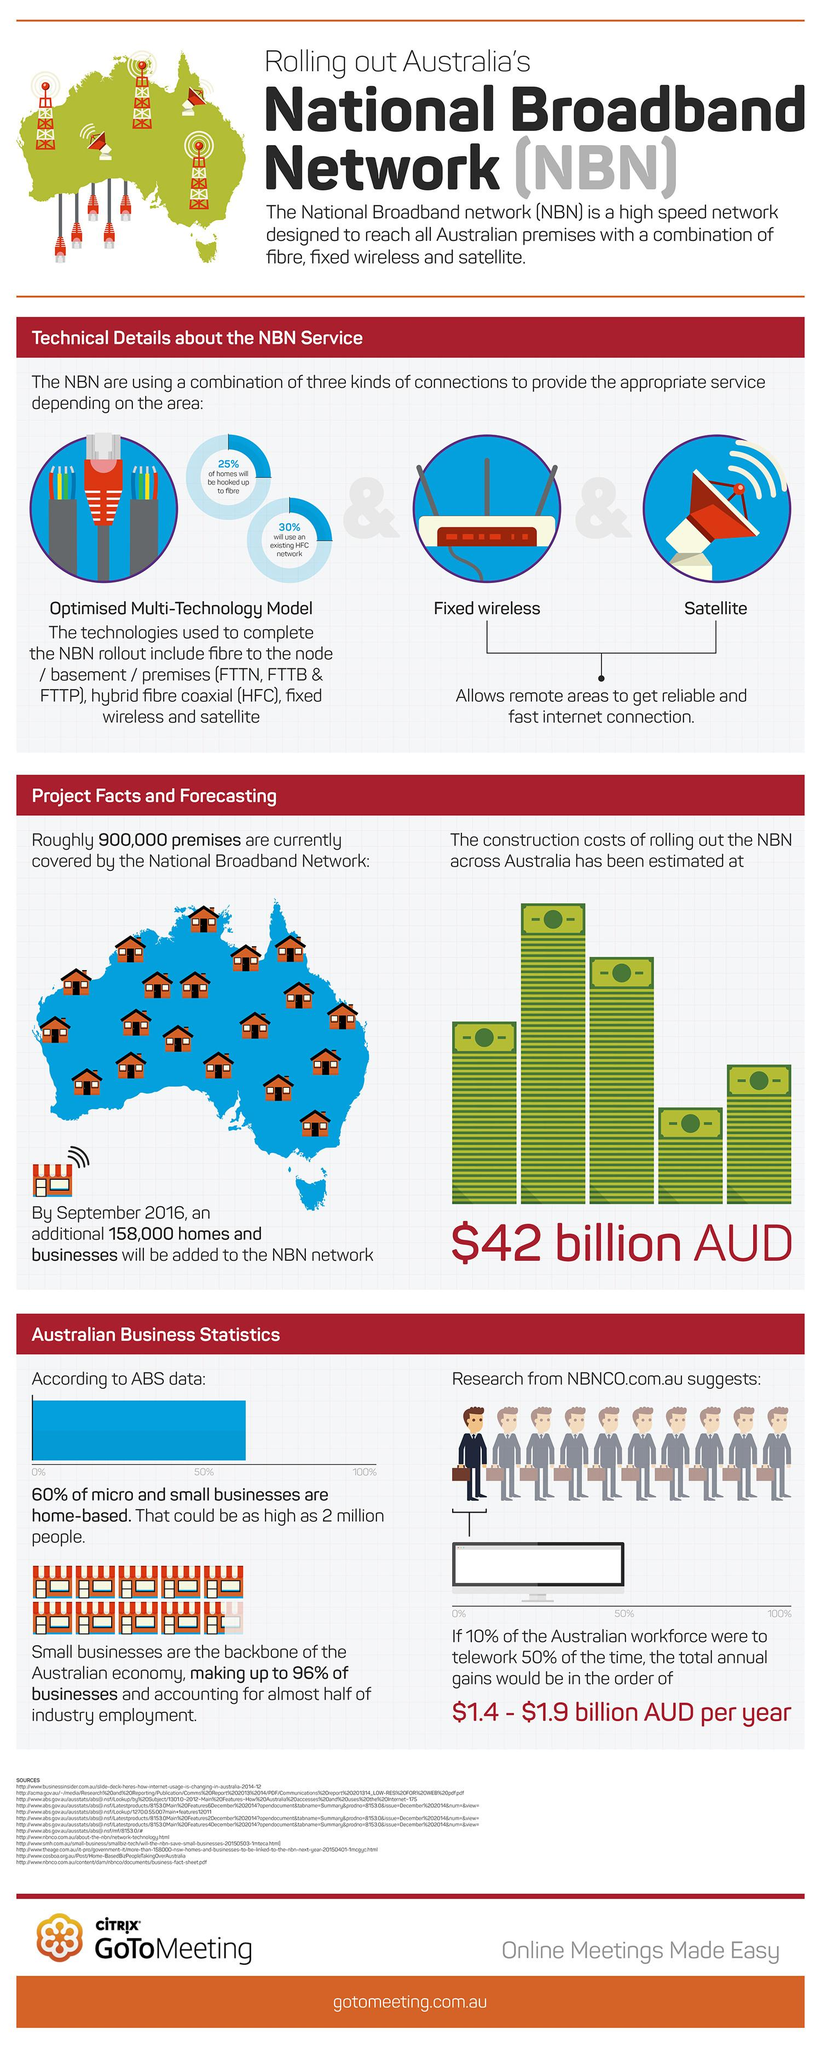List a handful of essential elements in this visual. According to a recent survey, 40% of micro and small businesses are not home-based. The availability of reliable and fast internet connections in remote areas is influenced by factors such as fixed wireless and satellite technologies. A small percentage of businesses in Australia are not considered small businesses. Specifically, 4% of businesses in Australia do not meet the definition of a small business. 